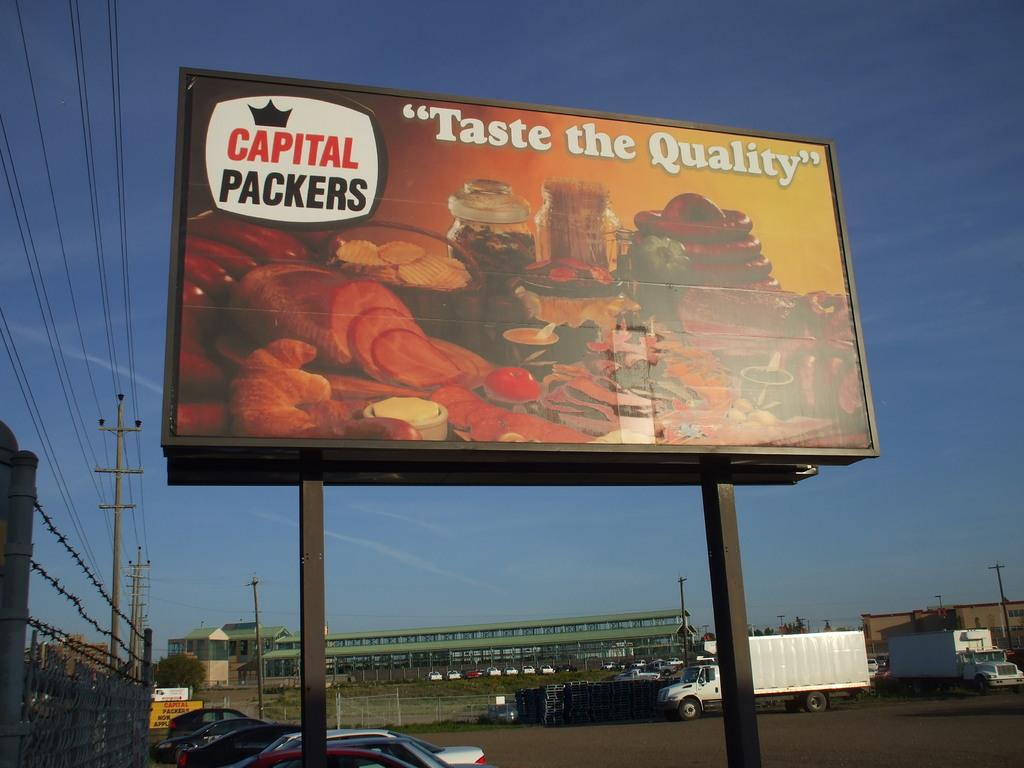<image>
Write a terse but informative summary of the picture. Billboard on display saying Taste the Quality by Capital  Packers. 